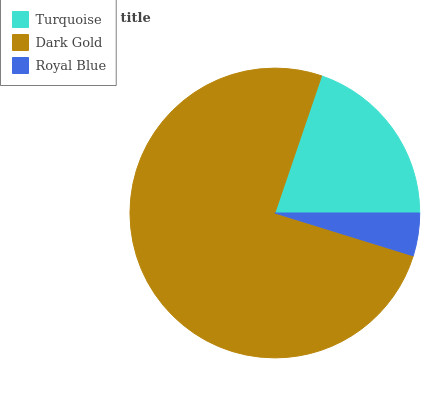Is Royal Blue the minimum?
Answer yes or no. Yes. Is Dark Gold the maximum?
Answer yes or no. Yes. Is Dark Gold the minimum?
Answer yes or no. No. Is Royal Blue the maximum?
Answer yes or no. No. Is Dark Gold greater than Royal Blue?
Answer yes or no. Yes. Is Royal Blue less than Dark Gold?
Answer yes or no. Yes. Is Royal Blue greater than Dark Gold?
Answer yes or no. No. Is Dark Gold less than Royal Blue?
Answer yes or no. No. Is Turquoise the high median?
Answer yes or no. Yes. Is Turquoise the low median?
Answer yes or no. Yes. Is Royal Blue the high median?
Answer yes or no. No. Is Royal Blue the low median?
Answer yes or no. No. 